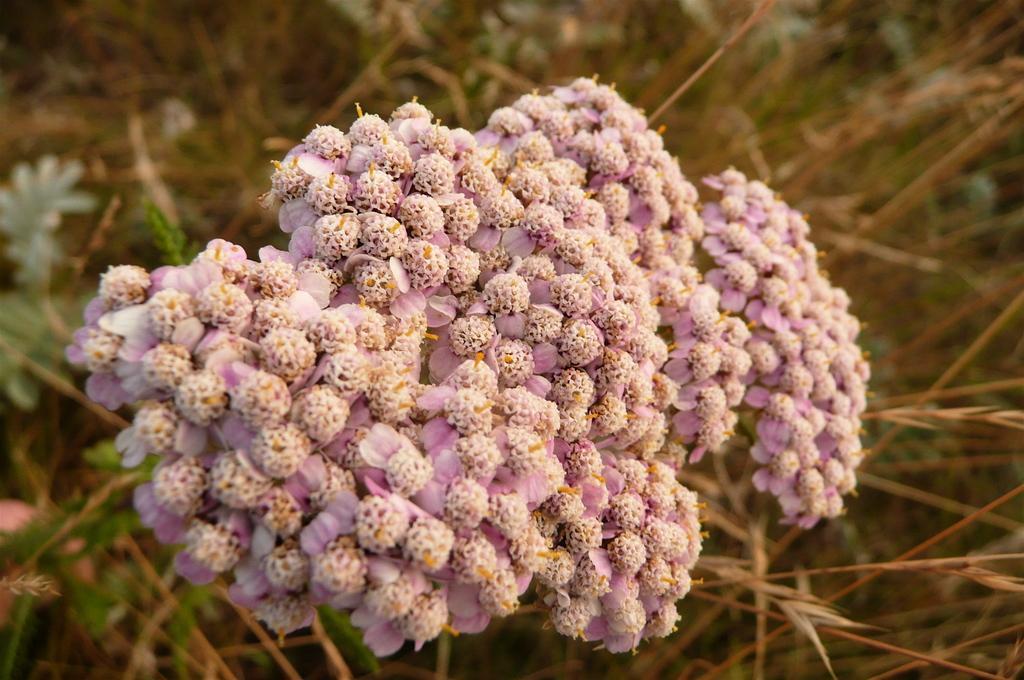How would you summarize this image in a sentence or two? In this image, we can see a bunch of flowers. Background there is a blur view. Here we can see few plants, flowers. 